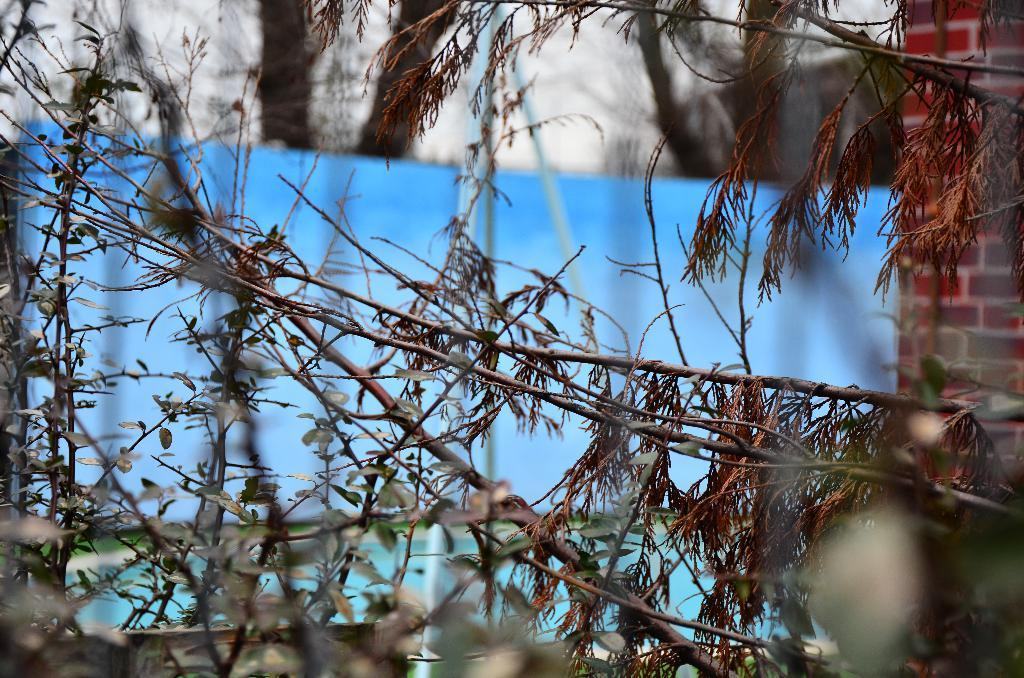What type of vegetation can be seen in the image? There are plants and trees in the image. What is located on the right side of the image? There is a brick wall on the right side of the image. What color is the cloth visible in the background of the image? There is a blue color cloth in the background of the image. What type of structure can be seen in the top background of the image? There is a building visible in the top background of the image. How many cats are sitting on the blue cloth in the image? There are no cats present in the image; it features plants, trees, a brick wall, and a building in the background. 